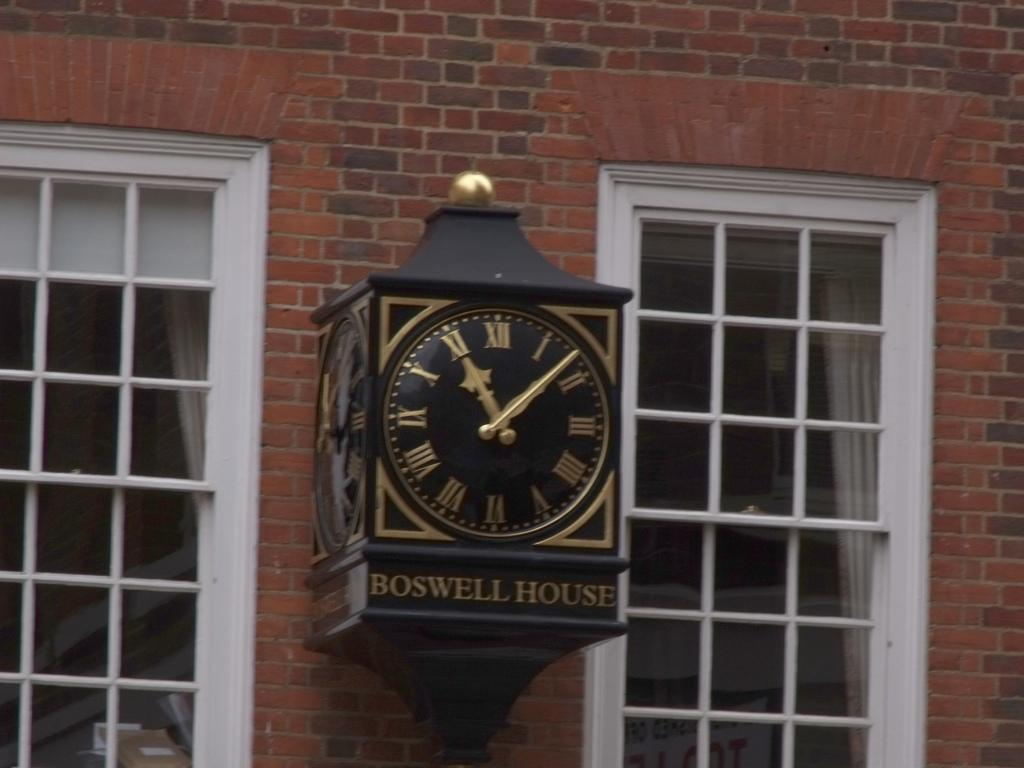<image>
Offer a succinct explanation of the picture presented. A clock labeled Boswell House has the time of 11:08. 